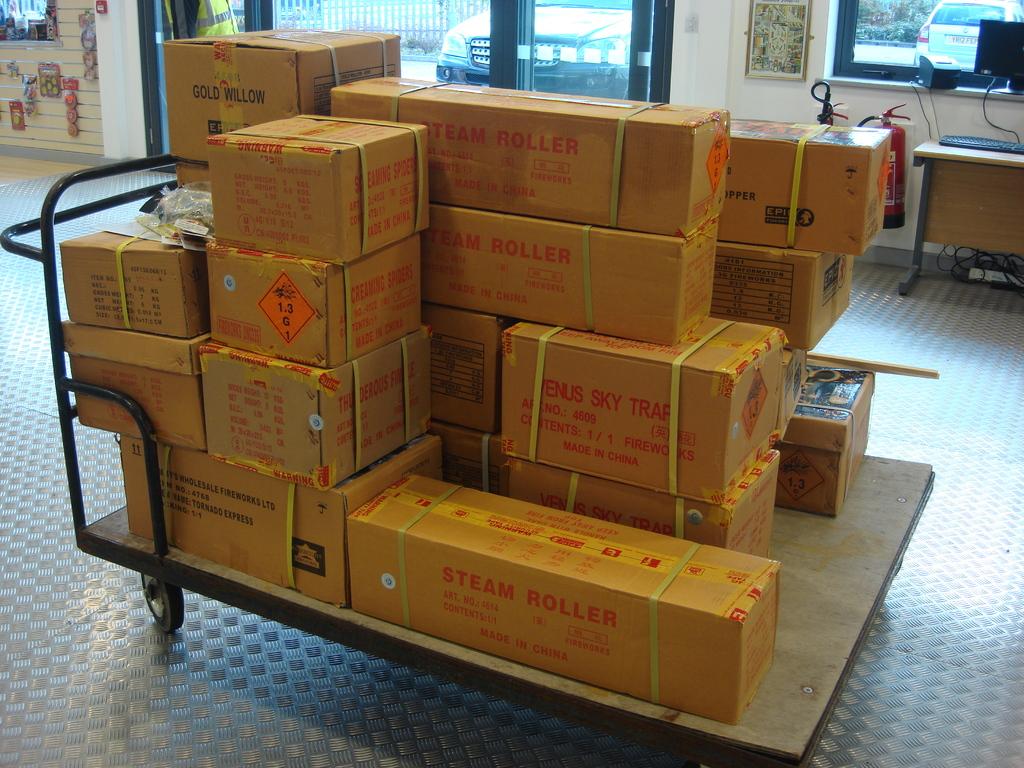What kind of roller is in the box?
Give a very brief answer. Steam. What are in the rectangular boxes?
Provide a short and direct response. Steam roller. 